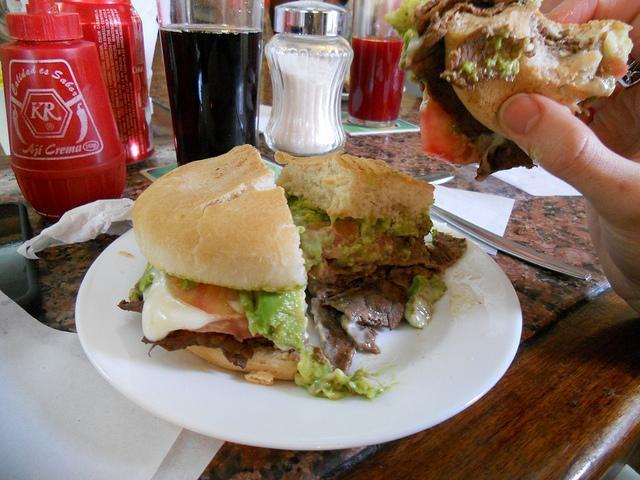What is she doing with the sandwich?
Indicate the correct choice and explain in the format: 'Answer: answer
Rationale: rationale.'
Options: Stealing it, cleaning it, sharing it, eating it. Answer: eating it.
Rationale: There are bite marks in it and she has it pulled up to her mouth 